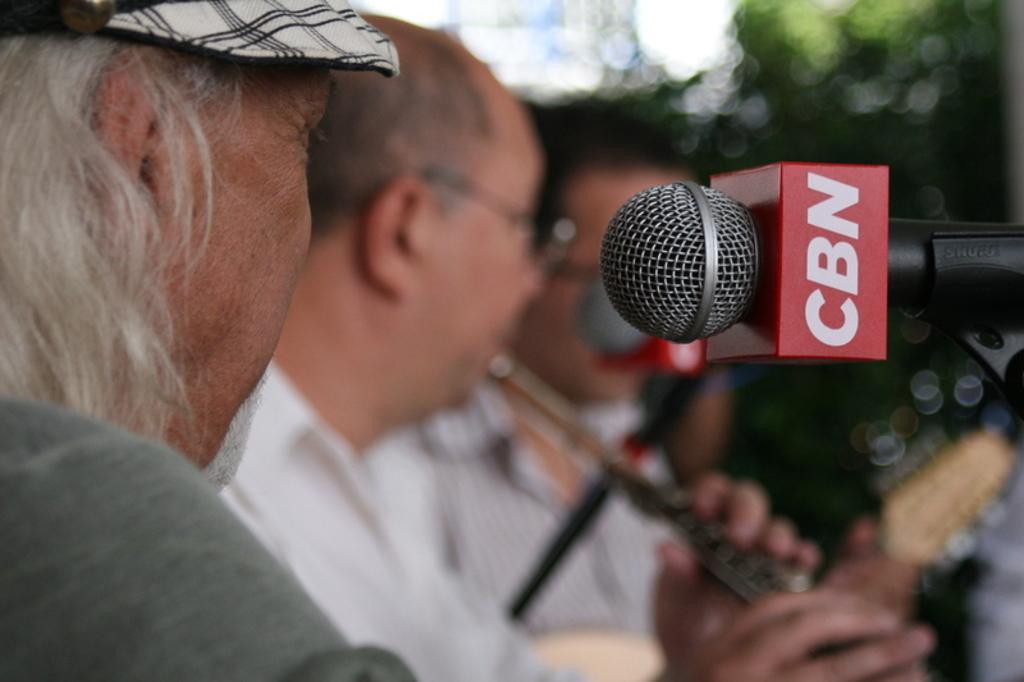In one or two sentences, can you explain what this image depicts? In this image on the right side, I can see a mike with some text written on it. On the left side I can see some people. 